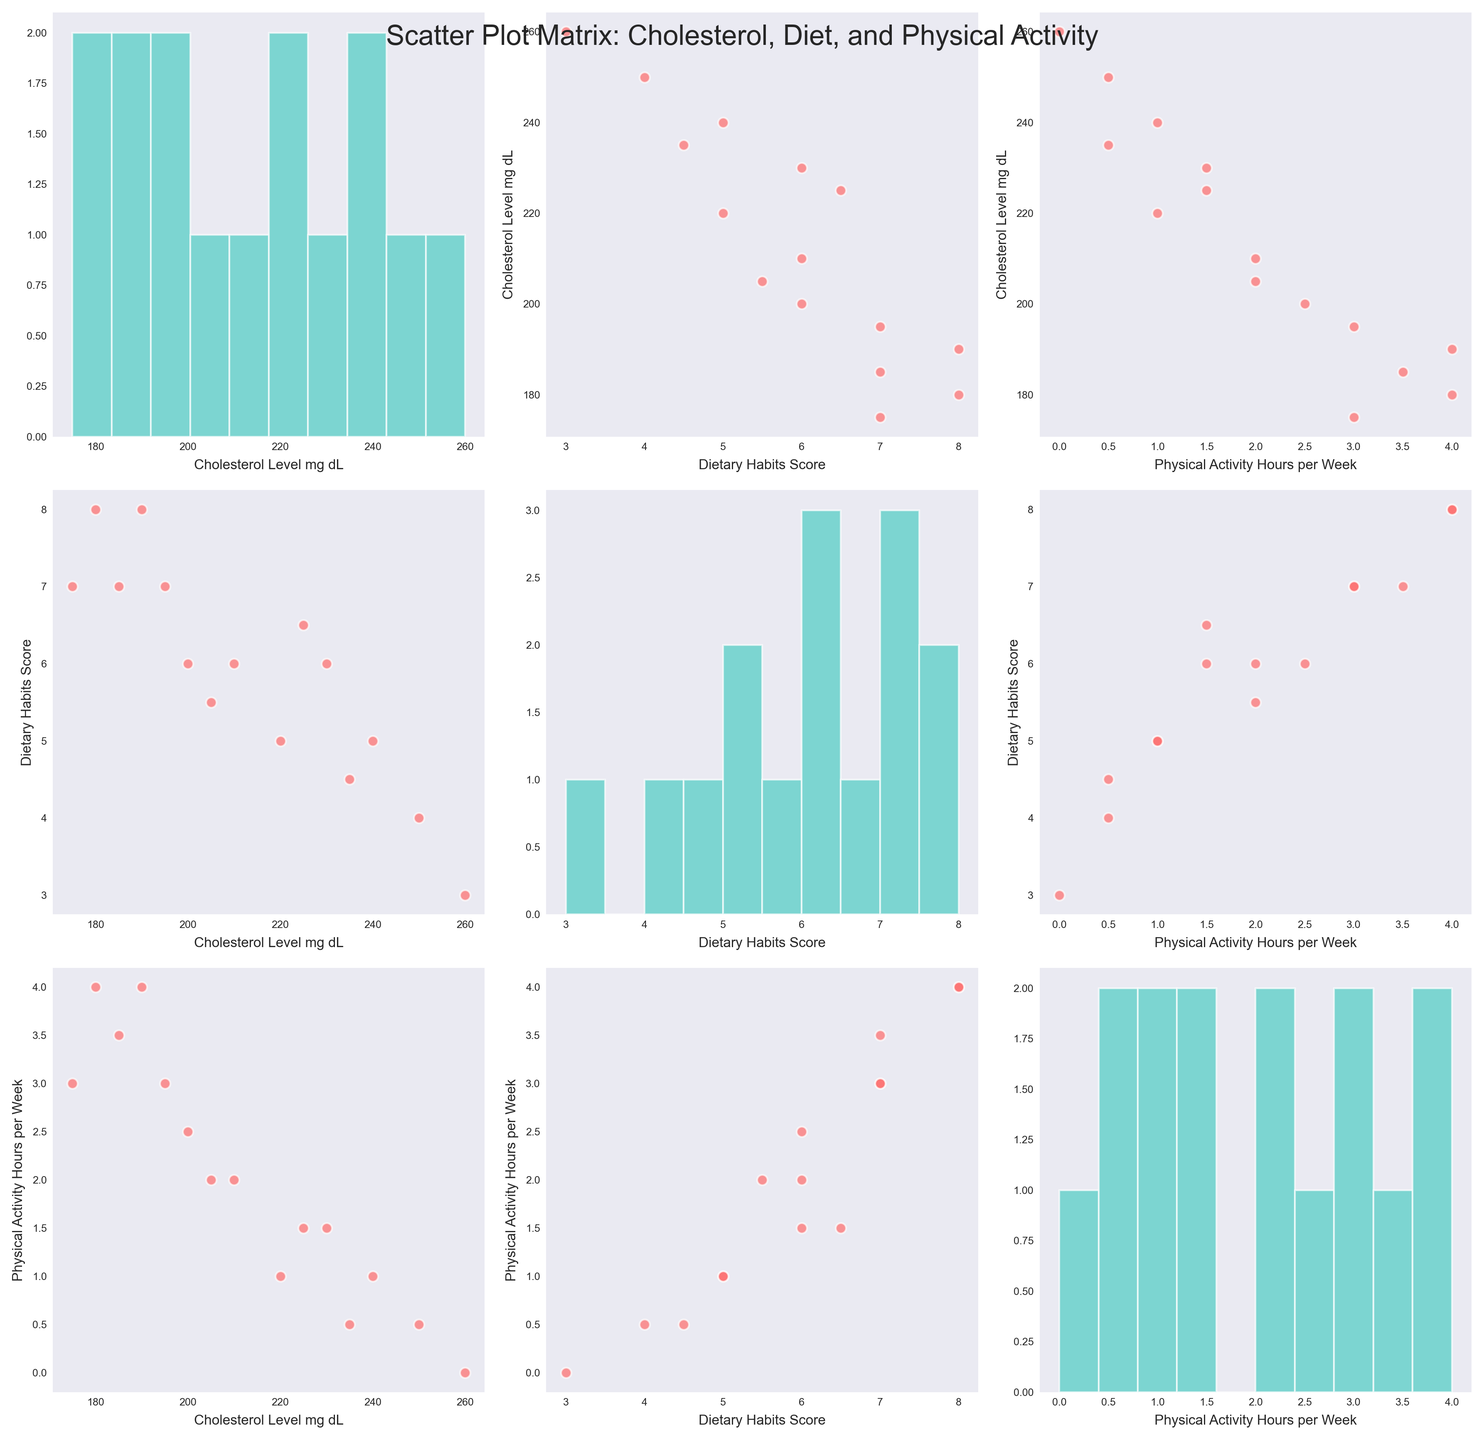What is the title of the figure? The title is usually displayed at the top of the figure. It provides a summary of what the figure represents.
Answer: Scatter Plot Matrix: Cholesterol, Diet, and Physical Activity Which variable is plotted against "Cholesterol_Level_mg_dL" in the middle row and first column? In the middle row (second row), and first column (first column) of the scatter plot matrix (SPLOM), the variable plotted against "Cholesterol_Level_mg_dL" is "Dietary_Habits_Score".
Answer: Dietary_Habits_Score What color are the scatter points in the scatter plots? The scatter points in the scatter plots are colored to stand out against the background. The color is generally chosen to provide contrast.
Answer: Red What can you infer about the relationship between physical activity and cholesterol levels? Observing the plots where "Physical_Activity_Hours_per_Week" is plotted against "Cholesterol_Level_mg_dL", we can observe a pattern in the scatter distribution.
Answer: Inverse correlation: higher physical activity tends to associate with lower cholesterol levels Which variable has the largest spread in the histogram? The histogram shows the distribution of values for a single variable. By comparing the overall shape and spread of the histograms, we can identify which variable has the most variation.
Answer: Cholesterol_Level_mg_dL How many patients have a dietary habits score greater than 6? First, locate the scatter plots or histograms involving the "Dietary_Habits_Score". Count the number of data points that lie on or beyond the score of 6.
Answer: 6 patients Are there any visible outliers in the data, particularly in the "Phyical_Activity_Hours_per_Week"? To identify outliers, look for data points that deviate significantly from the others in the scatter plots involving "Physical_Activity_Hours_per_Week".
Answer: Yes, some patients have 0 hours of physical activity Which patient has the highest cholesterol level and what are their dietary habits score and physical activity? By looking at the scatter plot matrix (SPLOM), find the highest value in the "Cholesterol_Level_mg_dL" axis and check the corresponding points in the "Dietary_Habits_Score" and "Physical_Activity_Hours_per_Week" axes.
Answer: Patient_9: 3 dietary, 0 activity Is there a trend between dietary habits and physical activity? In the scatter plot matrix (SPLOM), observe the bonding pattern of data points between "Dietary_Habits_Score" and "Physical_Activity_Hours_per_Week".
Answer: Positive correlation: higher dietary scores tend to correspond with more physical activity What is the median cholesterol level from the histogram? Count the total number of data points in the histogram for "Cholesterol_Level_mg_dL". Find the middle value in this sorted dataset.
Answer: 210 mg/dL 